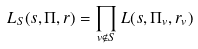<formula> <loc_0><loc_0><loc_500><loc_500>L _ { S } ( s , \Pi , r ) = \prod _ { v \notin S } L ( s , \Pi _ { v } , r _ { v } )</formula> 